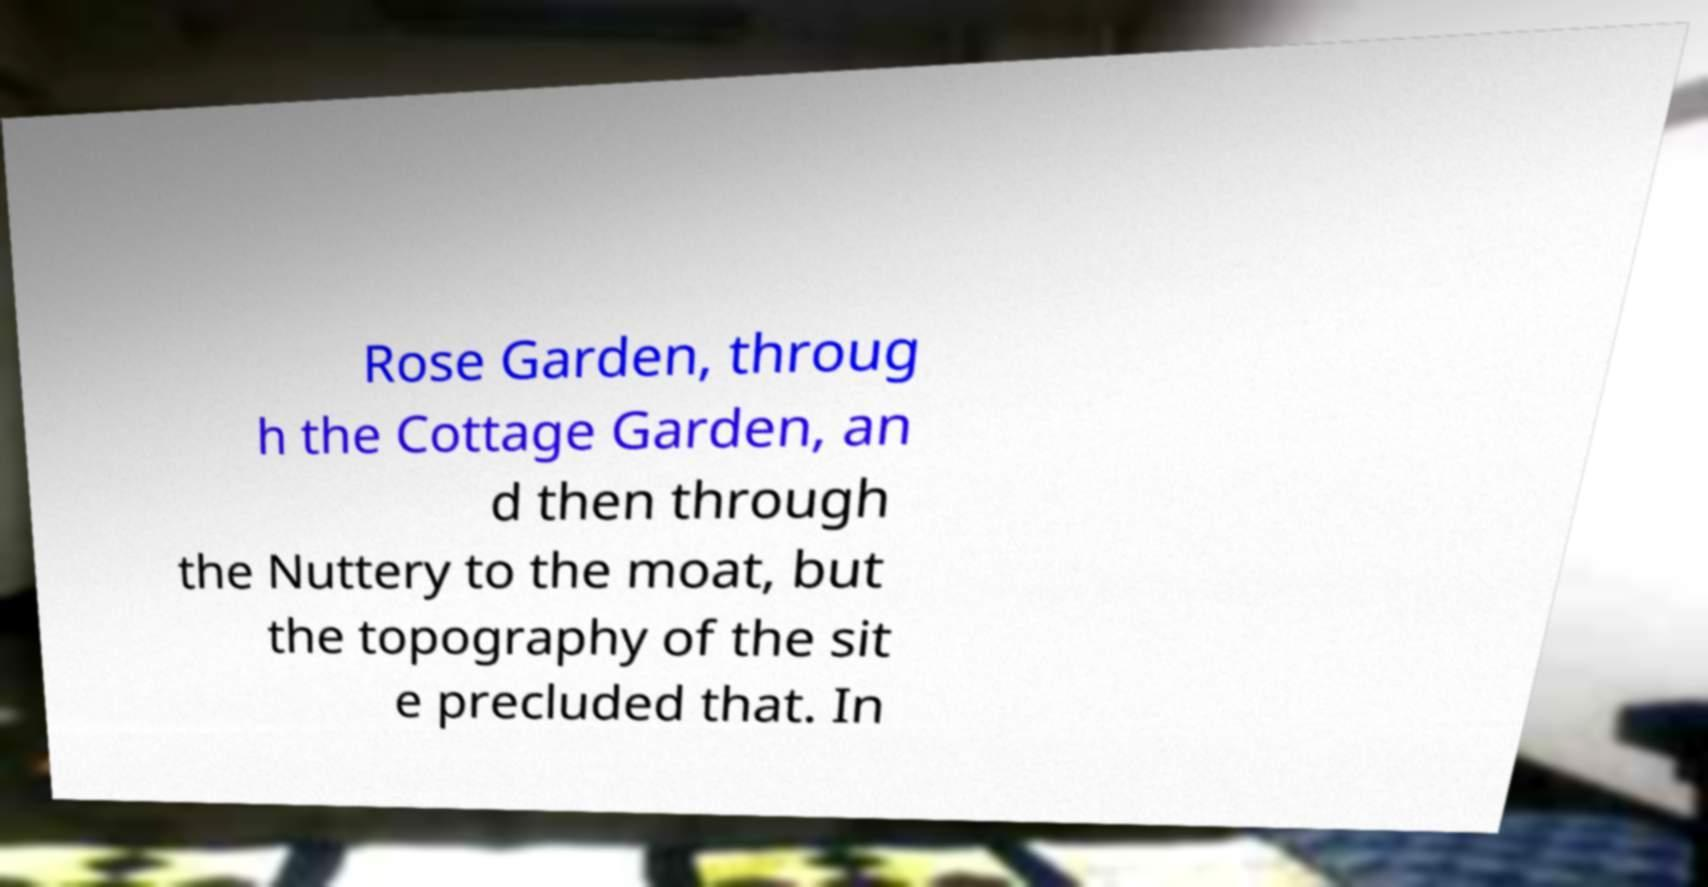I need the written content from this picture converted into text. Can you do that? Rose Garden, throug h the Cottage Garden, an d then through the Nuttery to the moat, but the topography of the sit e precluded that. In 